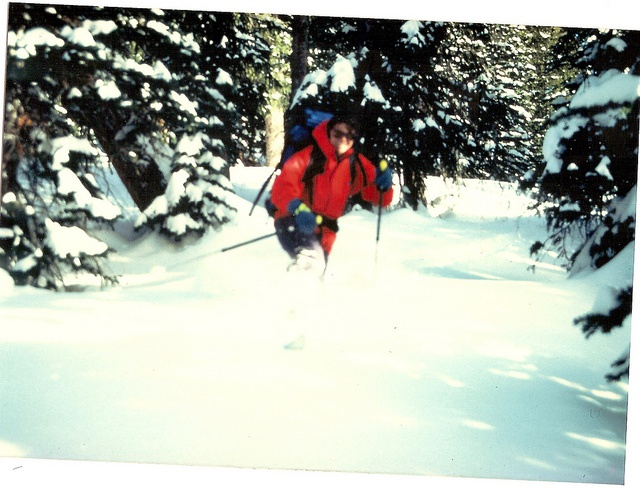Describe the objects in this image and their specific colors. I can see people in white, black, brown, and maroon tones and backpack in white, black, navy, blue, and gray tones in this image. 